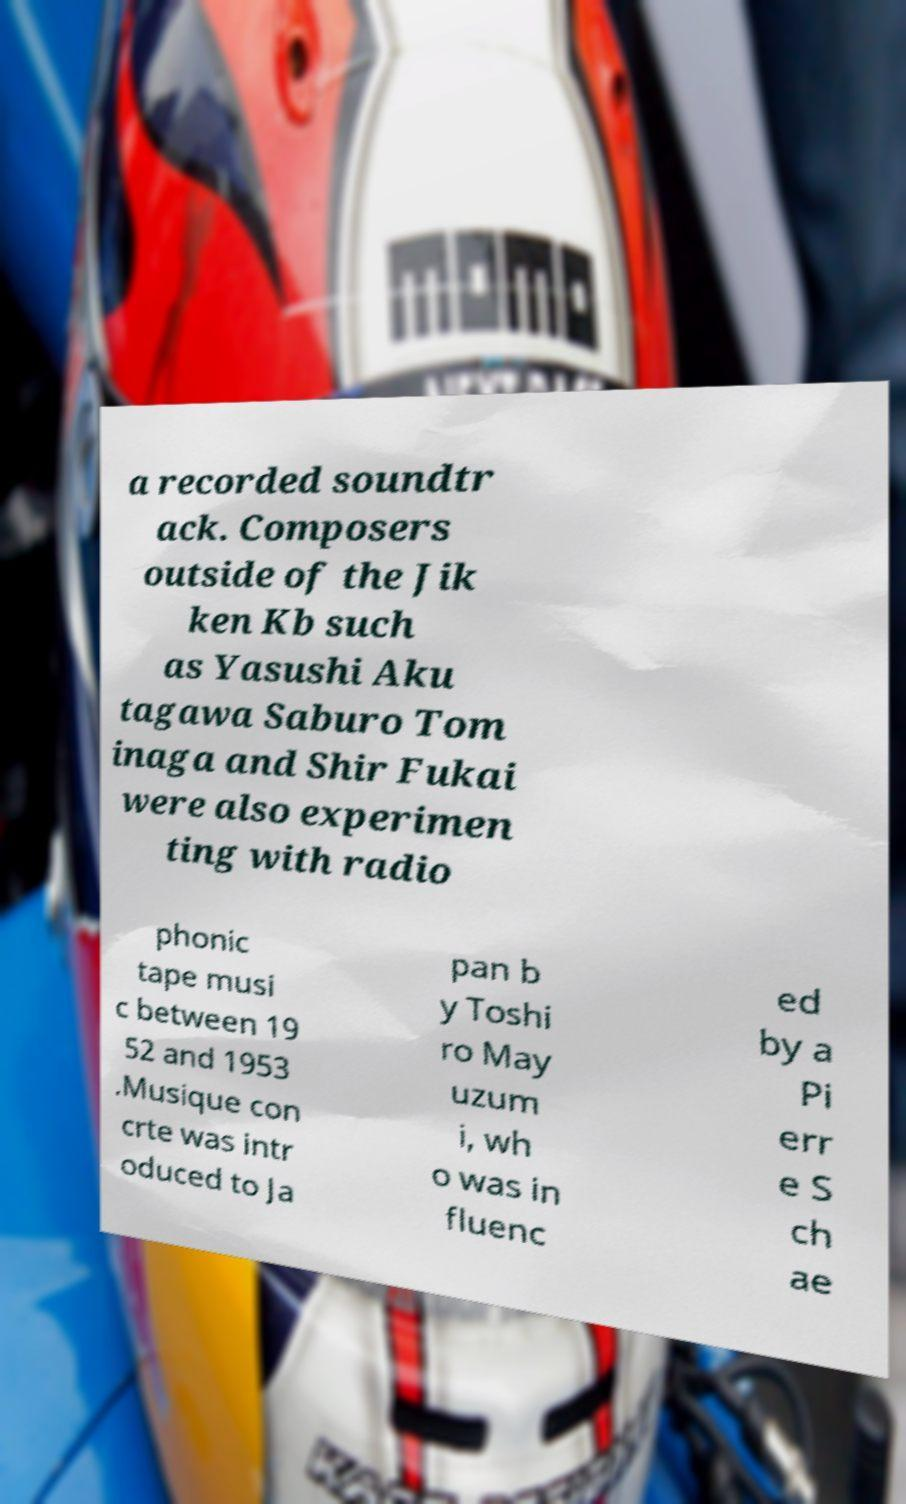There's text embedded in this image that I need extracted. Can you transcribe it verbatim? a recorded soundtr ack. Composers outside of the Jik ken Kb such as Yasushi Aku tagawa Saburo Tom inaga and Shir Fukai were also experimen ting with radio phonic tape musi c between 19 52 and 1953 .Musique con crte was intr oduced to Ja pan b y Toshi ro May uzum i, wh o was in fluenc ed by a Pi err e S ch ae 